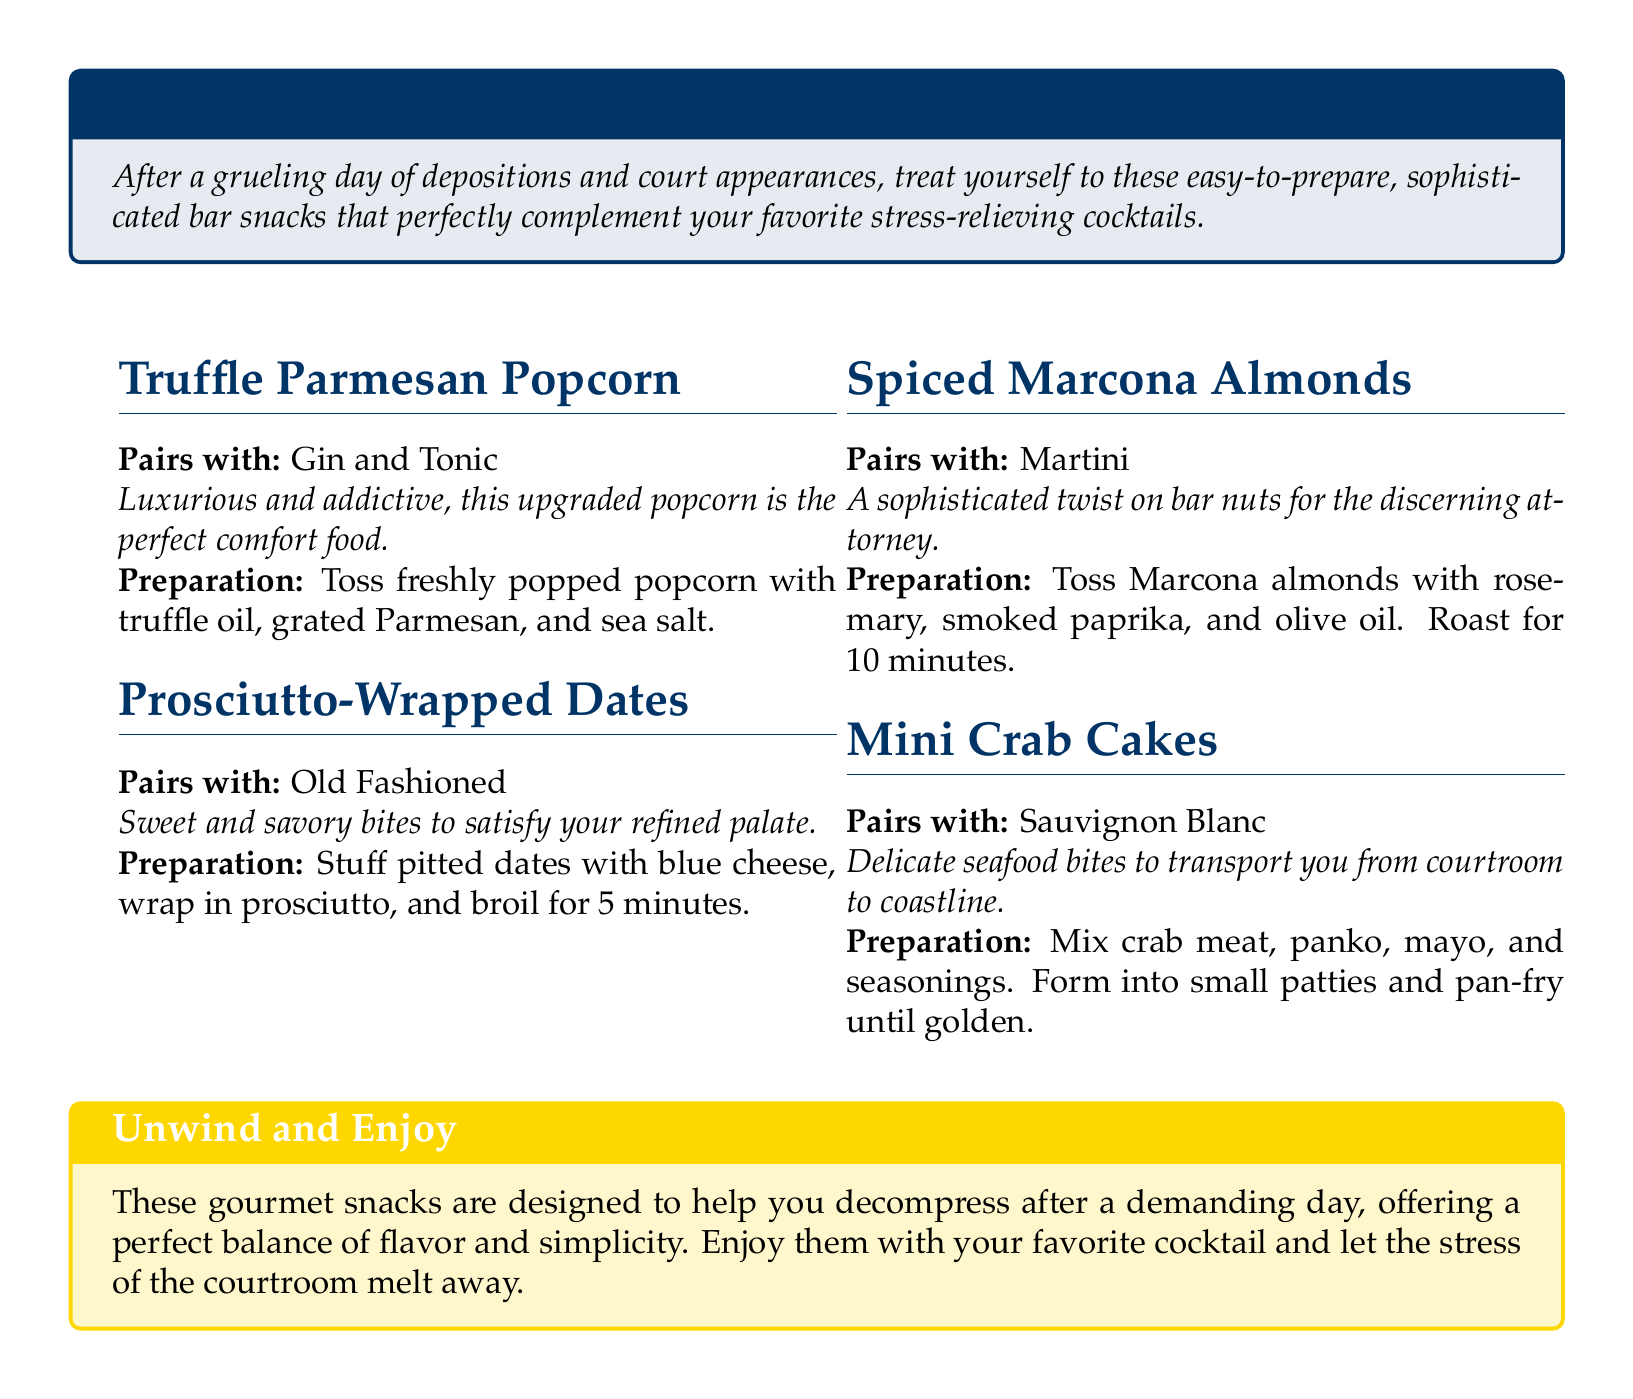What pairs with Truffle Parmesan Popcorn? The document states that Truffle Parmesan Popcorn pairs with Gin and Tonic.
Answer: Gin and Tonic What is the preparation method for Prosciutto-Wrapped Dates? The preparation involves stuffing pitted dates with blue cheese, wrapping them in prosciutto, and broiling for 5 minutes.
Answer: Stuff pitted dates with blue cheese, wrap in prosciutto, and broil for 5 minutes How long should Spiced Marcona Almonds be roasted? According to the document, Spiced Marcona Almonds should be roasted for 10 minutes.
Answer: 10 minutes What type of drink pairs with Mini Crab Cakes? The document indicates that Mini Crab Cakes pair with Sauvignon Blanc.
Answer: Sauvignon Blanc Which snack is described as “luxurious and addictive”? The document describes Truffle Parmesan Popcorn as luxurious and addictive.
Answer: Truffle Parmesan Popcorn How many appetizers are listed in the catalog? There are four appetizers listed in the document.
Answer: Four What flavor profile do Prosciutto-Wrapped Dates offer? The document describes the flavor profile of Prosciutto-Wrapped Dates as sweet and savory.
Answer: Sweet and savory What is the main ingredient in Mini Crab Cakes? The main ingredient in Mini Crab Cakes is crab meat.
Answer: Crab meat What provides a sophisticated twist on bar nuts? The document states that Spiced Marcona Almonds provide a sophisticated twist on bar nuts.
Answer: Spiced Marcona Almonds 